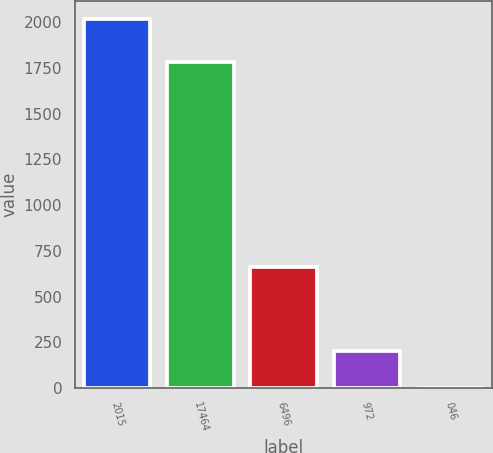Convert chart to OTSL. <chart><loc_0><loc_0><loc_500><loc_500><bar_chart><fcel>2015<fcel>17464<fcel>6496<fcel>972<fcel>046<nl><fcel>2015<fcel>1785<fcel>663.8<fcel>201.62<fcel>0.13<nl></chart> 